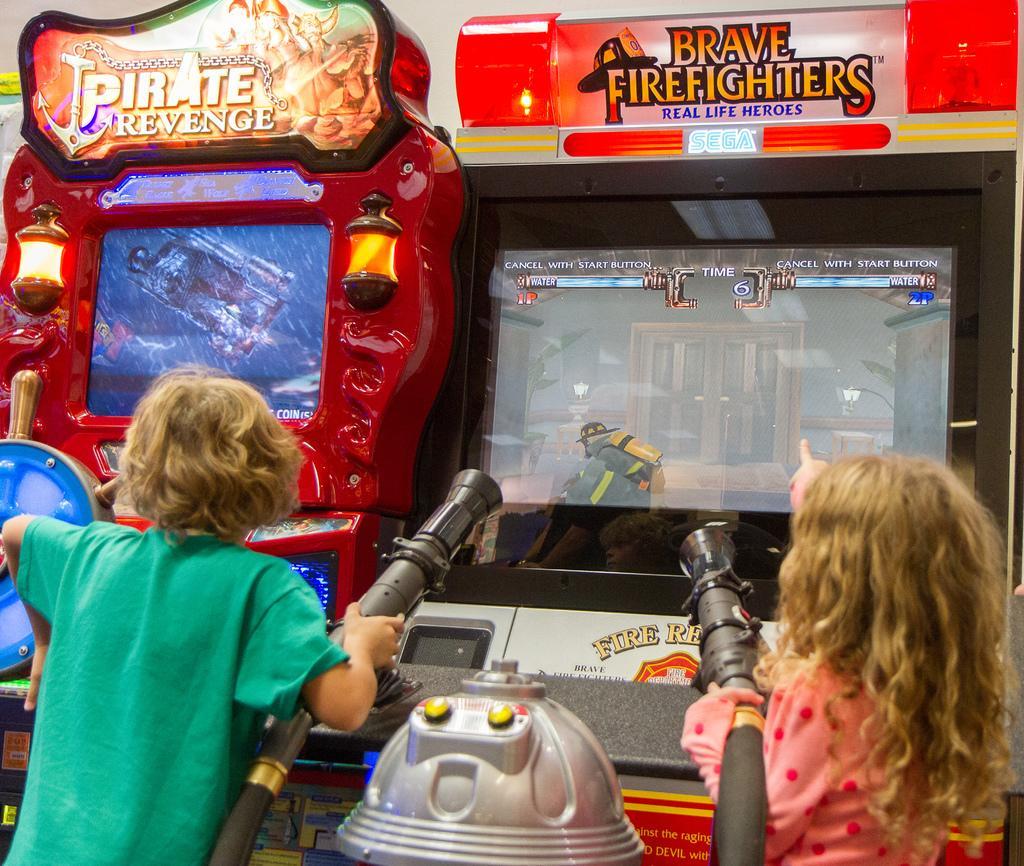How would you summarize this image in a sentence or two? These two kids are standing and holding pipes,in front of these two kids we can see game machines. 